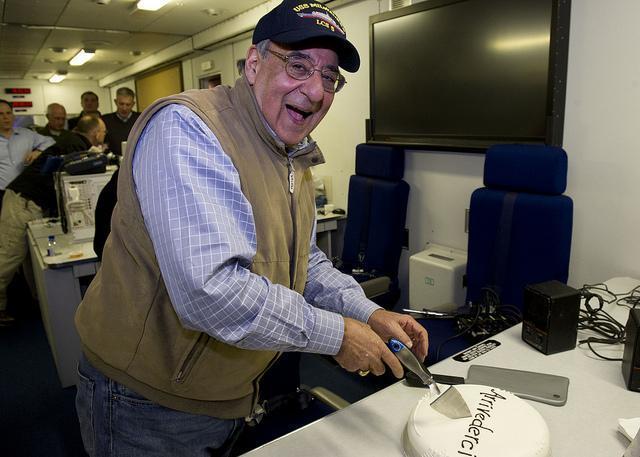How many cakes are there?
Give a very brief answer. 1. How many dining tables are visible?
Give a very brief answer. 1. How many chairs are there?
Give a very brief answer. 2. How many tvs are there?
Give a very brief answer. 1. How many people are in the photo?
Give a very brief answer. 3. 